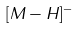Convert formula to latex. <formula><loc_0><loc_0><loc_500><loc_500>[ M - H ] ^ { - }</formula> 